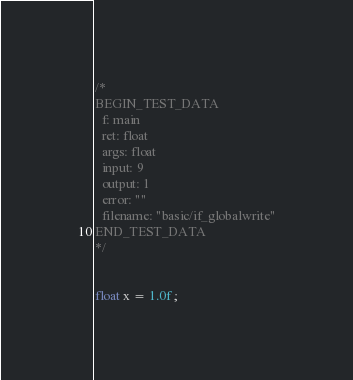<code> <loc_0><loc_0><loc_500><loc_500><_C_>/*
BEGIN_TEST_DATA
  f: main
  ret: float
  args: float
  input: 9
  output: 1
  error: ""
  filename: "basic/if_globalwrite"
END_TEST_DATA
*/


float x = 1.0f; 
</code> 